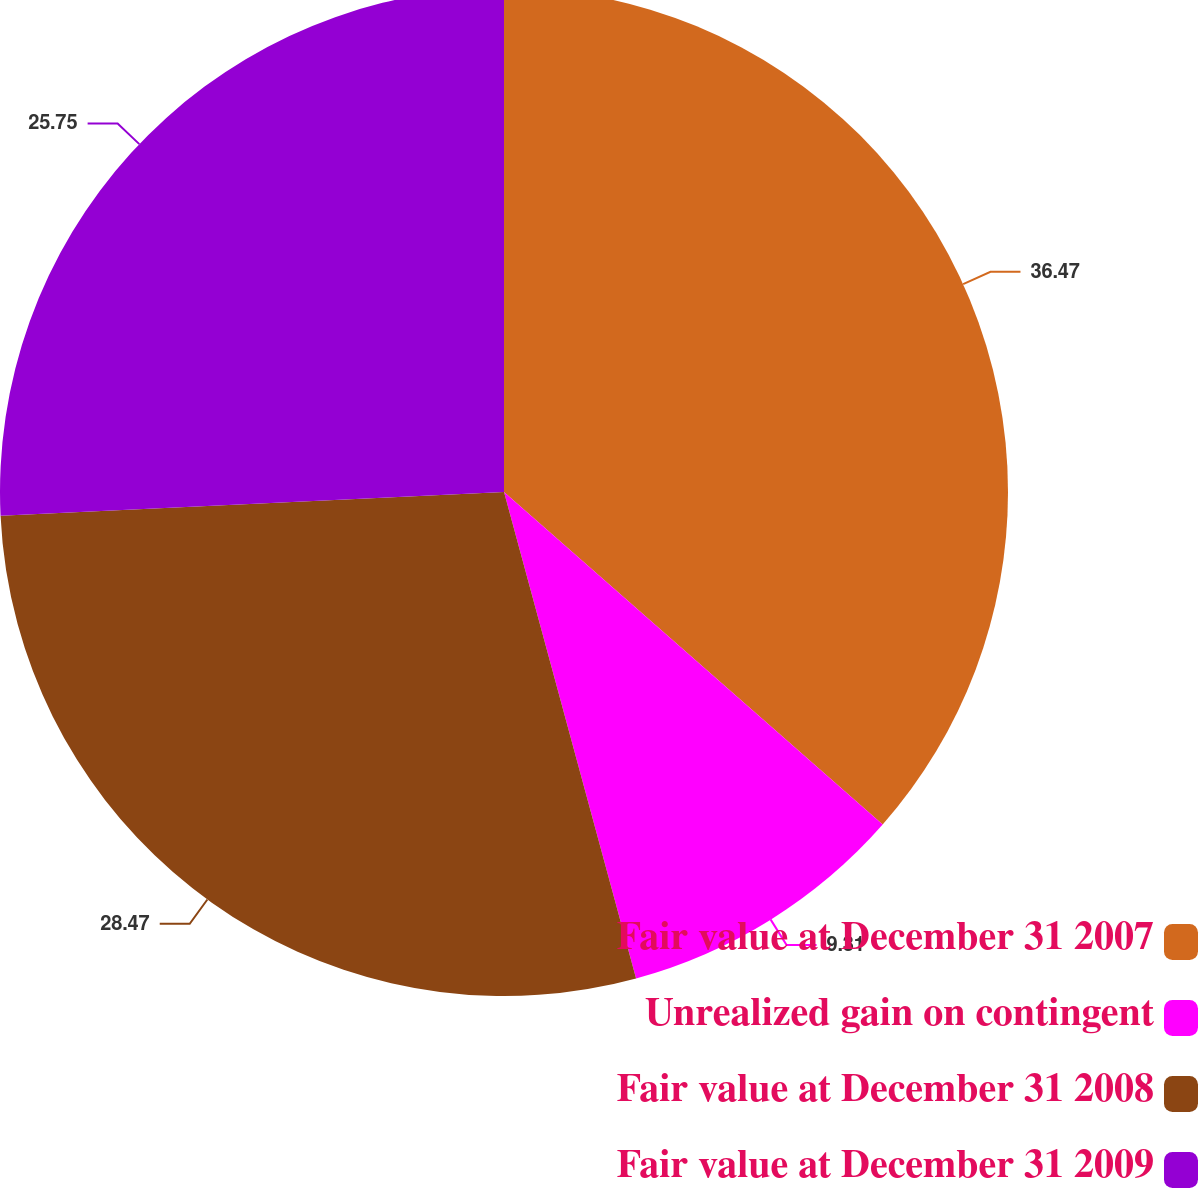Convert chart to OTSL. <chart><loc_0><loc_0><loc_500><loc_500><pie_chart><fcel>Fair value at December 31 2007<fcel>Unrealized gain on contingent<fcel>Fair value at December 31 2008<fcel>Fair value at December 31 2009<nl><fcel>36.47%<fcel>9.31%<fcel>28.47%<fcel>25.75%<nl></chart> 